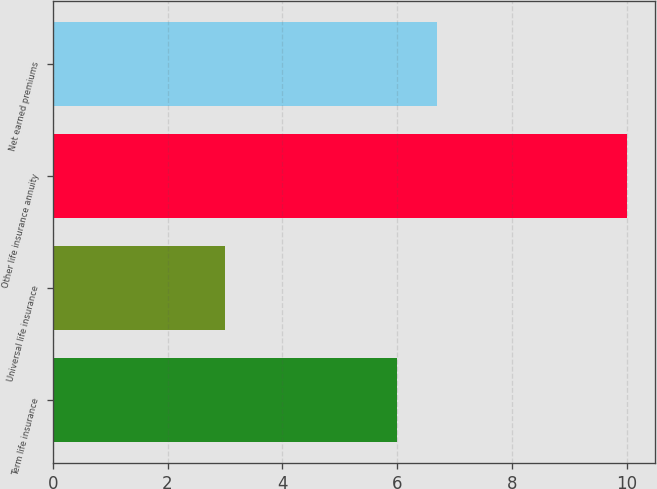Convert chart to OTSL. <chart><loc_0><loc_0><loc_500><loc_500><bar_chart><fcel>Term life insurance<fcel>Universal life insurance<fcel>Other life insurance annuity<fcel>Net earned premiums<nl><fcel>6<fcel>3<fcel>10<fcel>6.7<nl></chart> 